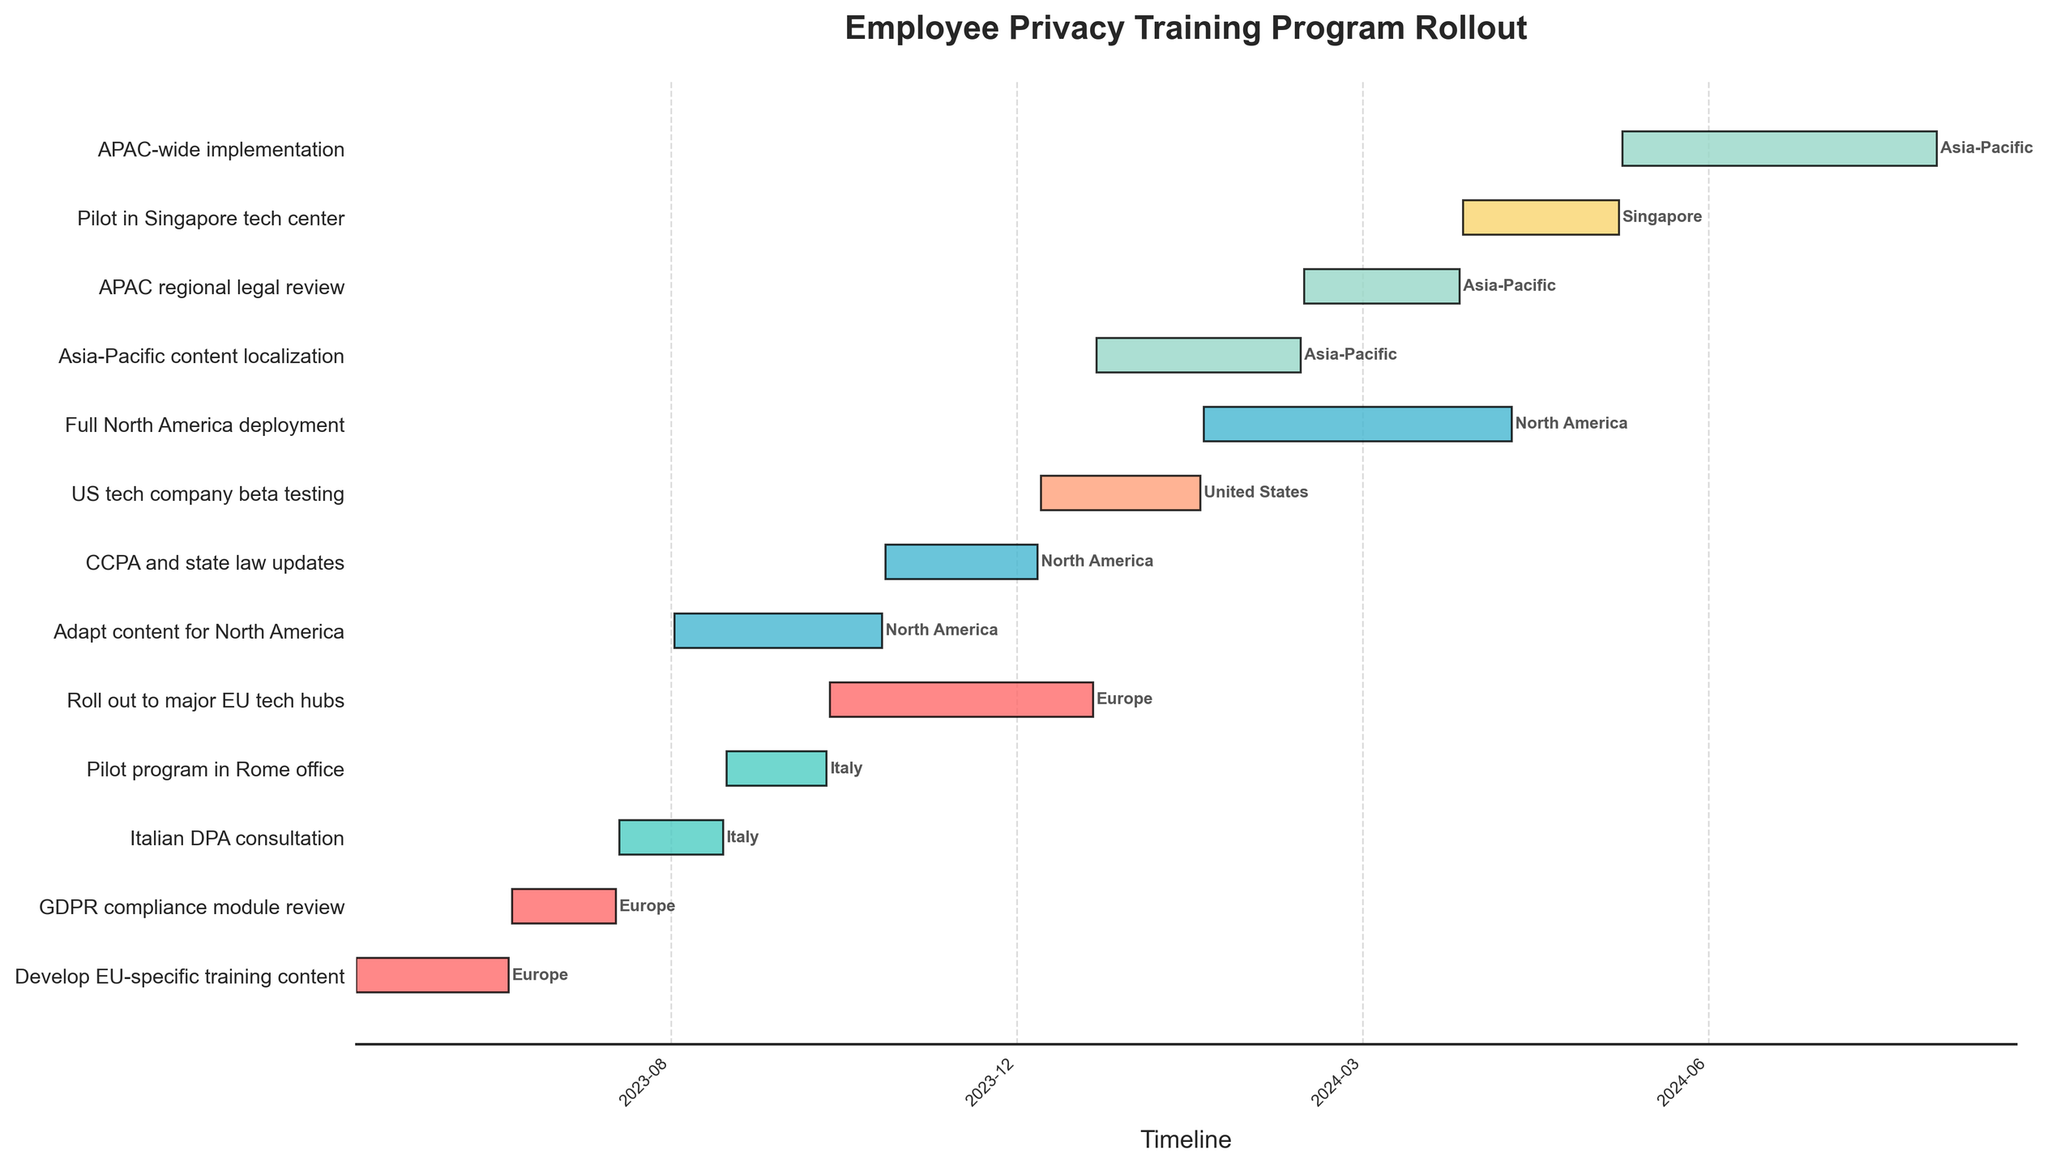Which task starts the latest on the Gantt chart? Identify the tasks and their respective start dates from the Gantt chart, then find the one with the latest start date. The task with the start date of 2024-06-01 is "APAC-wide implementation".
Answer: APAC-wide implementation How long does the "Pilot program in Rome office" take? Locate the task "Pilot program in Rome office" on the chart and observe the length of the bar representing it. The start date is 2023-09-16 and the end date is 2023-10-15, which spans 30 days.
Answer: 30 days Which region has the most tasks? Count the number of task bars corresponding to each region by their color on the Gantt chart. Europe has the most tasks with a total of 3.
Answer: Europe What is the duration of the "Roll out to major EU tech hubs" task? Identify the task "Roll out to major EU tech hubs" and note its start and end dates. Subtract the start date (2023-10-16) from the end date (2023-12-31) to calculate the duration, which is 76 days.
Answer: 76 days What tasks take place in North America? Observe the color representing North America (light blue) and identify the tasks assigned to this region. The tasks are "Adapt content for North America", "CCPA and state law updates", and "Full North America deployment".
Answer: Adapt content for North America, CCPA and state law updates, Full North America deployment Which task spans multiple years? Look for tasks that start in one year and end in another. The task "Roll out to major EU tech hubs" spans from 2023-10-16 to 2023-12-31.
Answer: Roll out to major EU tech hubs Which task has the shortest duration? Compare the length of bars for all tasks to find the shortest one. "Asia-Pacific content localization" has the shortest duration from 2024-01-01 to 2024-02-29, which spans 59 days (since 2024 is a leap year).
Answer: Asia-Pacific content localization During which months does the "US tech company beta testing" task occur? Locate the task "US tech company beta testing" and note its time span on the chart. The task runs from December 2023 to January 2024.
Answer: December 2023 to January 2024 What tasks are conducted in Italy, and what are their durations? Identify the tasks related to Italy by their color (light green) and calculate their durations. The tasks are "Italian DPA consultation" (spanning 31 days from 2023-08-16 to 2023-09-15) and "Pilot program in Rome office" (30 days from 2023-09-16 to 2023-10-15).
Answer: Italian DPA consultation: 31 days, Pilot program in Rome office: 30 days Which two regions have tasks running concurrently during November 2023? Find the tasks running in November 2023 and note their regions. Both "Roll out to major EU tech hubs" (Europe) and "CCPA and state law updates" (North America) occur during this month.
Answer: Europe, North America 